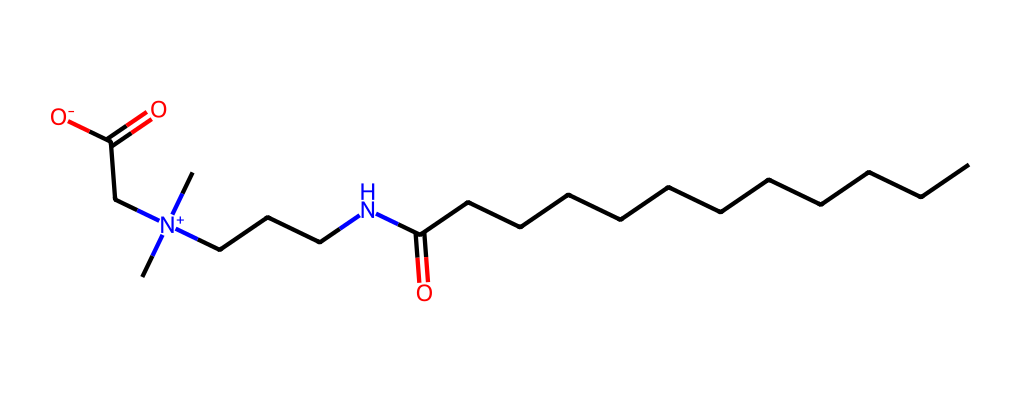What is the name of this chemical? The SMILES representation corresponds to cocamidopropyl betaine, which is commonly recognized as a mild surfactant.
Answer: cocamidopropyl betaine How many carbon atoms are in the structure? Counting the 'C' symbols in the SMILES representation and considering the structure, there are a total of 19 carbon atoms present.
Answer: 19 What type of chemical is cocamidopropyl betaine? This chemical is classified as an amphoteric surfactant, due to its ability to act as either an acid or a base, depending on the pH of the solution.
Answer: amphoteric surfactant How many nitrogen atoms are present in the structure? Analyzing the SMILES, there are 2 nitrogen (N) atoms indicated in the structure, completing the count of nitrogen in the molecule.
Answer: 2 What functional groups are present in cocamidopropyl betaine? The structure contains carboxyl (-COOH) and amine (-NH-) functional groups, which are characteristic of betaine molecules.
Answer: carboxyl and amine Why is cocamidopropyl betaine considered a gentle surfactant? The presence of hydrophilic (water-attracting) and lipophilic (oil-attracting) characteristics, along with its mild nature, attribute to its classification as a gentle surfactant in personal care products.
Answer: hydrophilic and lipophilic What charge does the nitrogen have in cocamidopropyl betaine? The nitrogen in cocamidopropyl betaine carries a positive charge, as indicated by the '[N+]' notation in the SMILES representation.
Answer: positive charge 